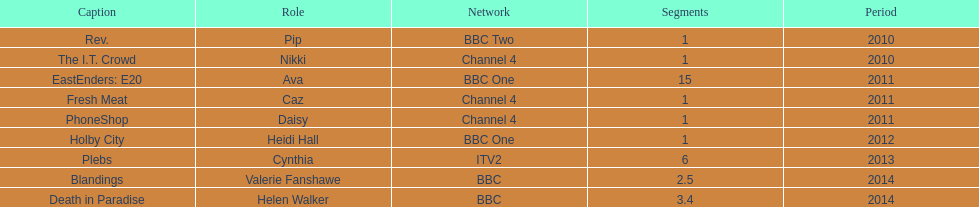Which broadcaster hosted 3 titles but they had only 1 episode? Channel 4. 